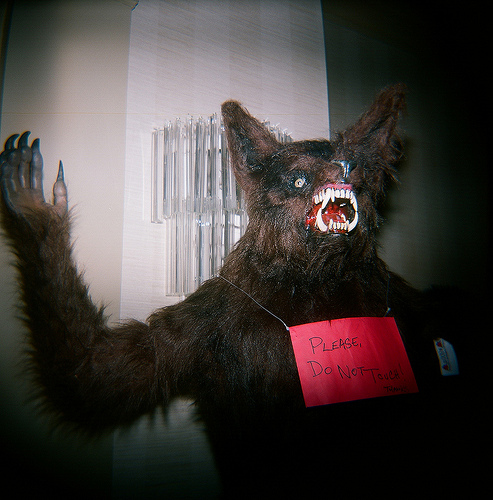<image>
Is the sign on the wall? No. The sign is not positioned on the wall. They may be near each other, but the sign is not supported by or resting on top of the wall. Is the wall behind the ghost? Yes. From this viewpoint, the wall is positioned behind the ghost, with the ghost partially or fully occluding the wall. Is the bear behind the sign? Yes. From this viewpoint, the bear is positioned behind the sign, with the sign partially or fully occluding the bear. 